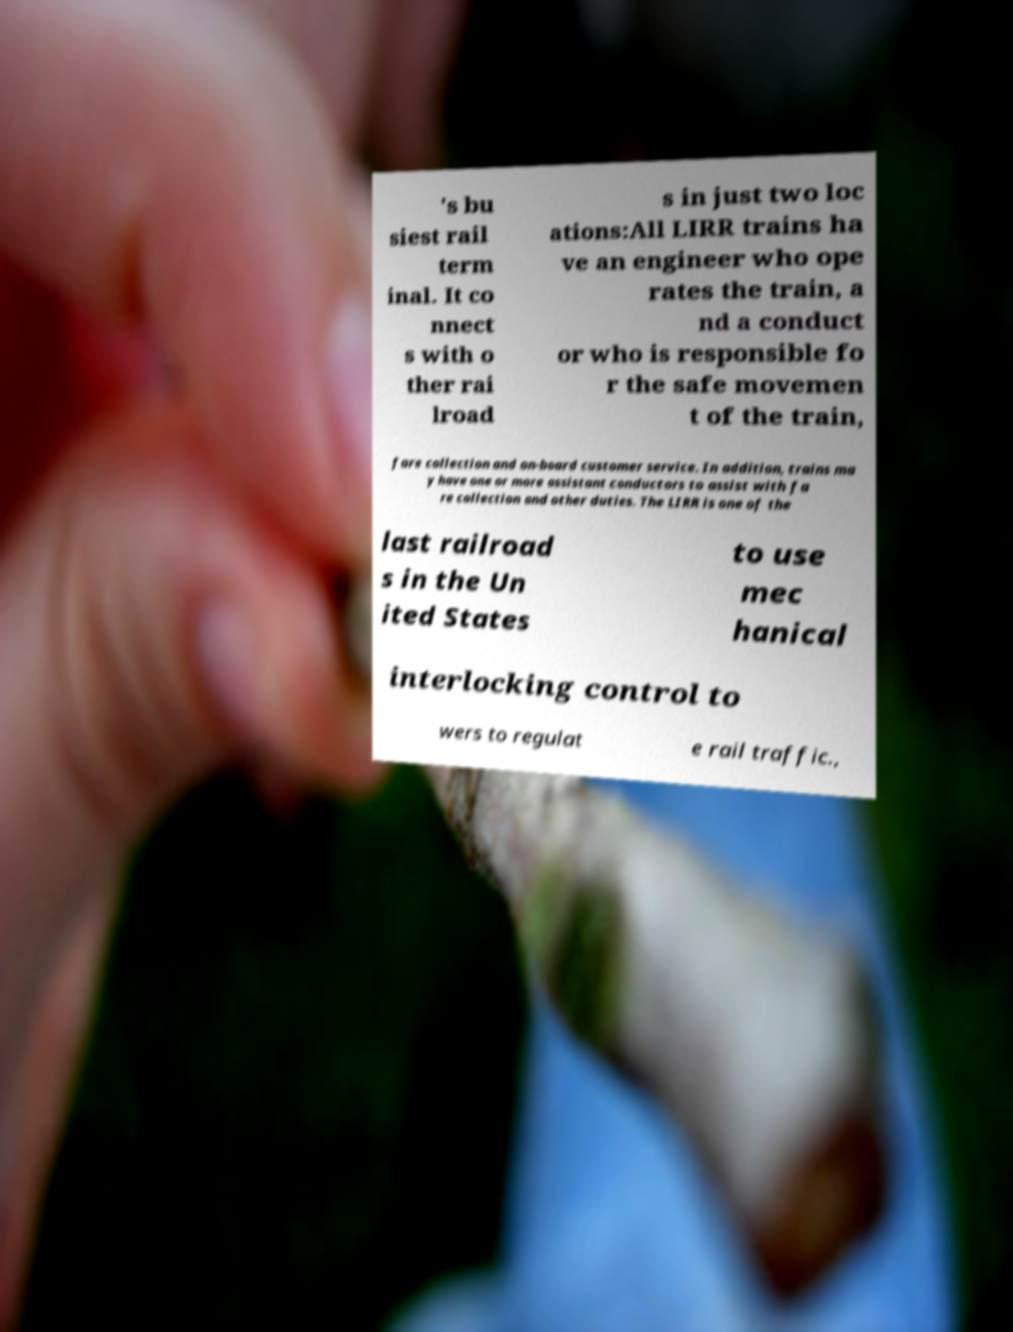Can you accurately transcribe the text from the provided image for me? 's bu siest rail term inal. It co nnect s with o ther rai lroad s in just two loc ations:All LIRR trains ha ve an engineer who ope rates the train, a nd a conduct or who is responsible fo r the safe movemen t of the train, fare collection and on-board customer service. In addition, trains ma y have one or more assistant conductors to assist with fa re collection and other duties. The LIRR is one of the last railroad s in the Un ited States to use mec hanical interlocking control to wers to regulat e rail traffic., 